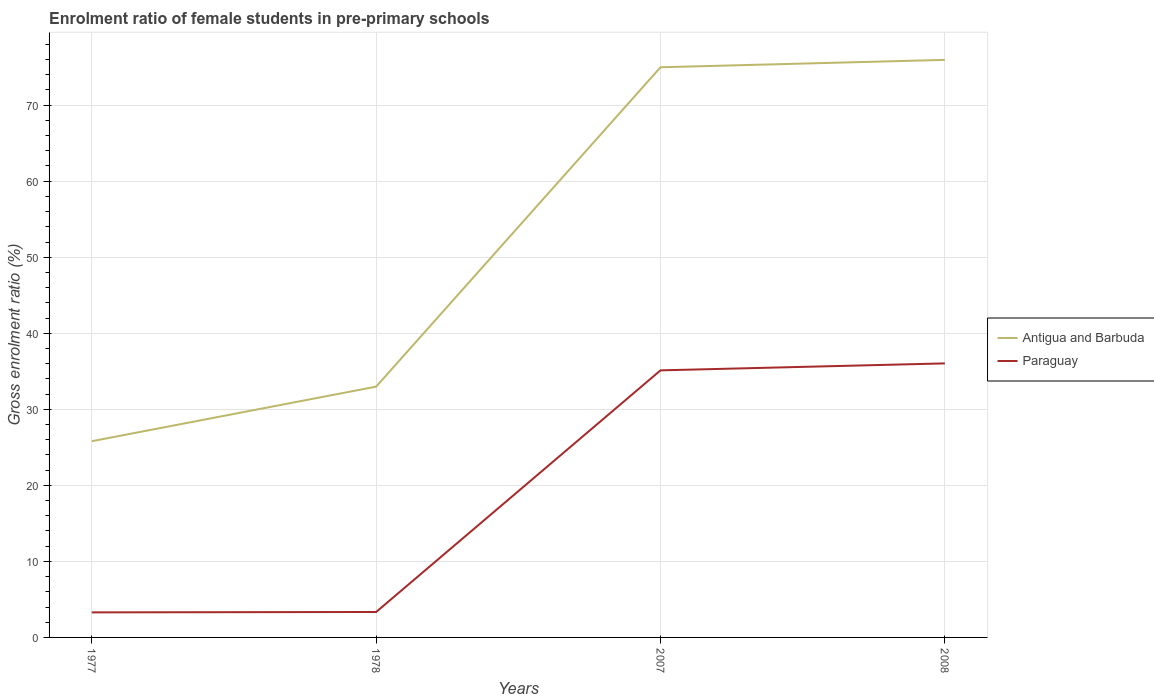How many different coloured lines are there?
Offer a very short reply. 2. Across all years, what is the maximum enrolment ratio of female students in pre-primary schools in Paraguay?
Your answer should be very brief. 3.29. In which year was the enrolment ratio of female students in pre-primary schools in Paraguay maximum?
Make the answer very short. 1977. What is the total enrolment ratio of female students in pre-primary schools in Antigua and Barbuda in the graph?
Provide a succinct answer. -0.97. What is the difference between the highest and the second highest enrolment ratio of female students in pre-primary schools in Antigua and Barbuda?
Give a very brief answer. 50.15. How many lines are there?
Give a very brief answer. 2. What is the difference between two consecutive major ticks on the Y-axis?
Give a very brief answer. 10. Does the graph contain any zero values?
Keep it short and to the point. No. Does the graph contain grids?
Give a very brief answer. Yes. How are the legend labels stacked?
Your response must be concise. Vertical. What is the title of the graph?
Your answer should be compact. Enrolment ratio of female students in pre-primary schools. What is the label or title of the X-axis?
Make the answer very short. Years. What is the label or title of the Y-axis?
Ensure brevity in your answer.  Gross enrolment ratio (%). What is the Gross enrolment ratio (%) of Antigua and Barbuda in 1977?
Offer a very short reply. 25.8. What is the Gross enrolment ratio (%) of Paraguay in 1977?
Provide a succinct answer. 3.29. What is the Gross enrolment ratio (%) in Antigua and Barbuda in 1978?
Keep it short and to the point. 32.98. What is the Gross enrolment ratio (%) of Paraguay in 1978?
Offer a very short reply. 3.35. What is the Gross enrolment ratio (%) of Antigua and Barbuda in 2007?
Offer a very short reply. 74.98. What is the Gross enrolment ratio (%) of Paraguay in 2007?
Offer a very short reply. 35.12. What is the Gross enrolment ratio (%) of Antigua and Barbuda in 2008?
Your response must be concise. 75.96. What is the Gross enrolment ratio (%) in Paraguay in 2008?
Your answer should be very brief. 36.04. Across all years, what is the maximum Gross enrolment ratio (%) of Antigua and Barbuda?
Your response must be concise. 75.96. Across all years, what is the maximum Gross enrolment ratio (%) of Paraguay?
Your answer should be compact. 36.04. Across all years, what is the minimum Gross enrolment ratio (%) in Antigua and Barbuda?
Your response must be concise. 25.8. Across all years, what is the minimum Gross enrolment ratio (%) in Paraguay?
Provide a short and direct response. 3.29. What is the total Gross enrolment ratio (%) of Antigua and Barbuda in the graph?
Give a very brief answer. 209.73. What is the total Gross enrolment ratio (%) of Paraguay in the graph?
Your response must be concise. 77.8. What is the difference between the Gross enrolment ratio (%) of Antigua and Barbuda in 1977 and that in 1978?
Give a very brief answer. -7.18. What is the difference between the Gross enrolment ratio (%) of Paraguay in 1977 and that in 1978?
Provide a short and direct response. -0.05. What is the difference between the Gross enrolment ratio (%) of Antigua and Barbuda in 1977 and that in 2007?
Offer a terse response. -49.18. What is the difference between the Gross enrolment ratio (%) in Paraguay in 1977 and that in 2007?
Ensure brevity in your answer.  -31.83. What is the difference between the Gross enrolment ratio (%) of Antigua and Barbuda in 1977 and that in 2008?
Your answer should be compact. -50.15. What is the difference between the Gross enrolment ratio (%) of Paraguay in 1977 and that in 2008?
Offer a terse response. -32.75. What is the difference between the Gross enrolment ratio (%) of Antigua and Barbuda in 1978 and that in 2007?
Keep it short and to the point. -42. What is the difference between the Gross enrolment ratio (%) in Paraguay in 1978 and that in 2007?
Make the answer very short. -31.78. What is the difference between the Gross enrolment ratio (%) in Antigua and Barbuda in 1978 and that in 2008?
Provide a succinct answer. -42.97. What is the difference between the Gross enrolment ratio (%) in Paraguay in 1978 and that in 2008?
Offer a terse response. -32.69. What is the difference between the Gross enrolment ratio (%) in Antigua and Barbuda in 2007 and that in 2008?
Ensure brevity in your answer.  -0.97. What is the difference between the Gross enrolment ratio (%) in Paraguay in 2007 and that in 2008?
Ensure brevity in your answer.  -0.92. What is the difference between the Gross enrolment ratio (%) in Antigua and Barbuda in 1977 and the Gross enrolment ratio (%) in Paraguay in 1978?
Ensure brevity in your answer.  22.46. What is the difference between the Gross enrolment ratio (%) in Antigua and Barbuda in 1977 and the Gross enrolment ratio (%) in Paraguay in 2007?
Ensure brevity in your answer.  -9.32. What is the difference between the Gross enrolment ratio (%) in Antigua and Barbuda in 1977 and the Gross enrolment ratio (%) in Paraguay in 2008?
Provide a succinct answer. -10.24. What is the difference between the Gross enrolment ratio (%) of Antigua and Barbuda in 1978 and the Gross enrolment ratio (%) of Paraguay in 2007?
Keep it short and to the point. -2.14. What is the difference between the Gross enrolment ratio (%) of Antigua and Barbuda in 1978 and the Gross enrolment ratio (%) of Paraguay in 2008?
Your answer should be very brief. -3.06. What is the difference between the Gross enrolment ratio (%) of Antigua and Barbuda in 2007 and the Gross enrolment ratio (%) of Paraguay in 2008?
Give a very brief answer. 38.94. What is the average Gross enrolment ratio (%) of Antigua and Barbuda per year?
Keep it short and to the point. 52.43. What is the average Gross enrolment ratio (%) in Paraguay per year?
Keep it short and to the point. 19.45. In the year 1977, what is the difference between the Gross enrolment ratio (%) of Antigua and Barbuda and Gross enrolment ratio (%) of Paraguay?
Ensure brevity in your answer.  22.51. In the year 1978, what is the difference between the Gross enrolment ratio (%) of Antigua and Barbuda and Gross enrolment ratio (%) of Paraguay?
Make the answer very short. 29.64. In the year 2007, what is the difference between the Gross enrolment ratio (%) in Antigua and Barbuda and Gross enrolment ratio (%) in Paraguay?
Provide a short and direct response. 39.86. In the year 2008, what is the difference between the Gross enrolment ratio (%) in Antigua and Barbuda and Gross enrolment ratio (%) in Paraguay?
Your response must be concise. 39.92. What is the ratio of the Gross enrolment ratio (%) in Antigua and Barbuda in 1977 to that in 1978?
Ensure brevity in your answer.  0.78. What is the ratio of the Gross enrolment ratio (%) in Paraguay in 1977 to that in 1978?
Give a very brief answer. 0.98. What is the ratio of the Gross enrolment ratio (%) of Antigua and Barbuda in 1977 to that in 2007?
Your response must be concise. 0.34. What is the ratio of the Gross enrolment ratio (%) in Paraguay in 1977 to that in 2007?
Your answer should be compact. 0.09. What is the ratio of the Gross enrolment ratio (%) in Antigua and Barbuda in 1977 to that in 2008?
Your response must be concise. 0.34. What is the ratio of the Gross enrolment ratio (%) of Paraguay in 1977 to that in 2008?
Offer a very short reply. 0.09. What is the ratio of the Gross enrolment ratio (%) of Antigua and Barbuda in 1978 to that in 2007?
Your answer should be very brief. 0.44. What is the ratio of the Gross enrolment ratio (%) in Paraguay in 1978 to that in 2007?
Your answer should be compact. 0.1. What is the ratio of the Gross enrolment ratio (%) of Antigua and Barbuda in 1978 to that in 2008?
Keep it short and to the point. 0.43. What is the ratio of the Gross enrolment ratio (%) in Paraguay in 1978 to that in 2008?
Your response must be concise. 0.09. What is the ratio of the Gross enrolment ratio (%) of Antigua and Barbuda in 2007 to that in 2008?
Your answer should be very brief. 0.99. What is the ratio of the Gross enrolment ratio (%) of Paraguay in 2007 to that in 2008?
Your answer should be very brief. 0.97. What is the difference between the highest and the second highest Gross enrolment ratio (%) of Antigua and Barbuda?
Provide a short and direct response. 0.97. What is the difference between the highest and the second highest Gross enrolment ratio (%) of Paraguay?
Provide a succinct answer. 0.92. What is the difference between the highest and the lowest Gross enrolment ratio (%) in Antigua and Barbuda?
Offer a terse response. 50.15. What is the difference between the highest and the lowest Gross enrolment ratio (%) in Paraguay?
Ensure brevity in your answer.  32.75. 